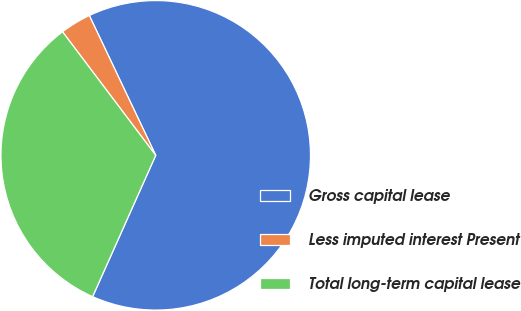Convert chart. <chart><loc_0><loc_0><loc_500><loc_500><pie_chart><fcel>Gross capital lease<fcel>Less imputed interest Present<fcel>Total long-term capital lease<nl><fcel>63.74%<fcel>3.23%<fcel>33.03%<nl></chart> 